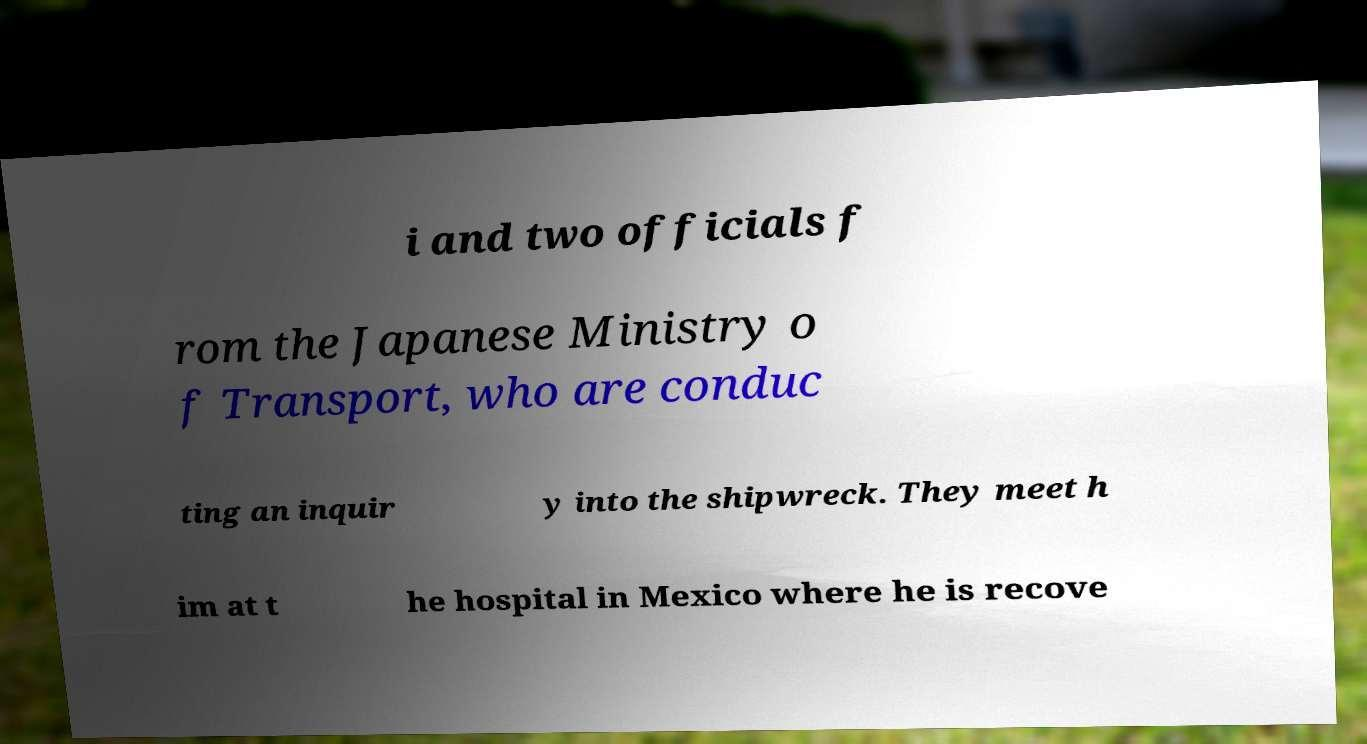What messages or text are displayed in this image? I need them in a readable, typed format. i and two officials f rom the Japanese Ministry o f Transport, who are conduc ting an inquir y into the shipwreck. They meet h im at t he hospital in Mexico where he is recove 